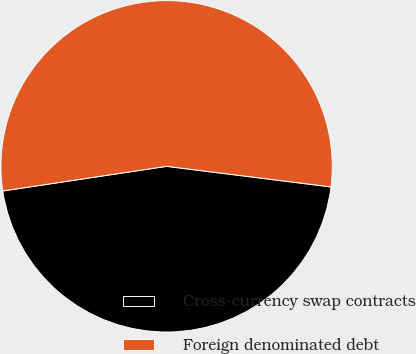Convert chart. <chart><loc_0><loc_0><loc_500><loc_500><pie_chart><fcel>Cross-currency swap contracts<fcel>Foreign denominated debt<nl><fcel>45.64%<fcel>54.36%<nl></chart> 